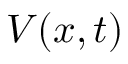Convert formula to latex. <formula><loc_0><loc_0><loc_500><loc_500>V ( x , t )</formula> 